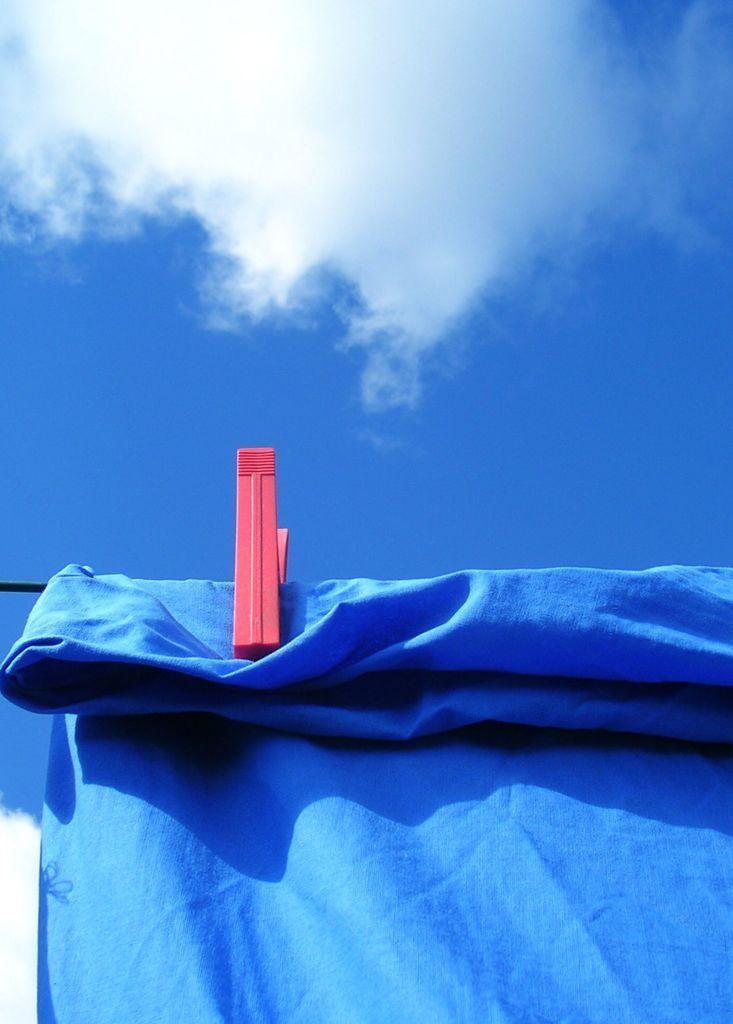Can you describe this image briefly? In this image, we can see a cloth hanging on the rope. There is a clip in the middle of the image. There is a cloud in the sky. 